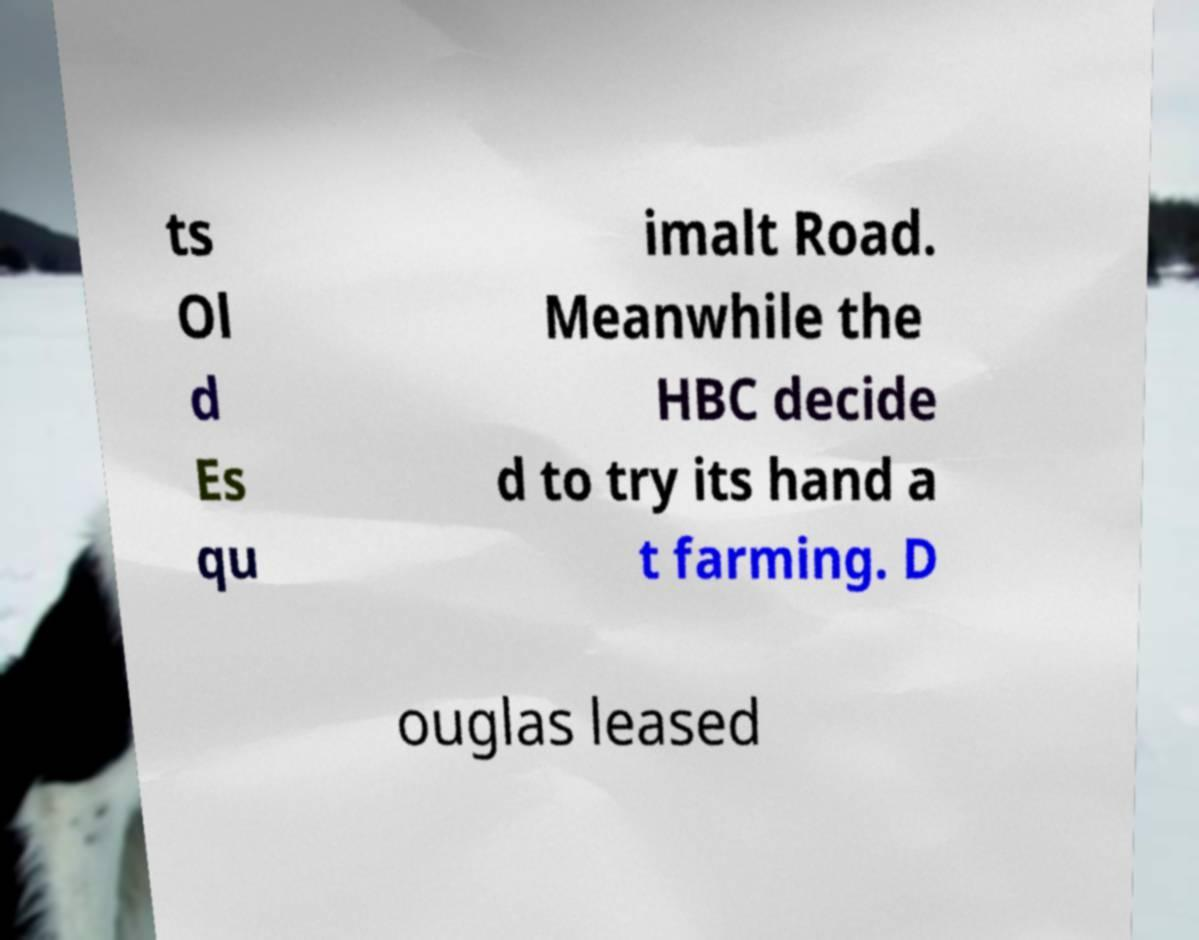Can you read and provide the text displayed in the image?This photo seems to have some interesting text. Can you extract and type it out for me? ts Ol d Es qu imalt Road. Meanwhile the HBC decide d to try its hand a t farming. D ouglas leased 